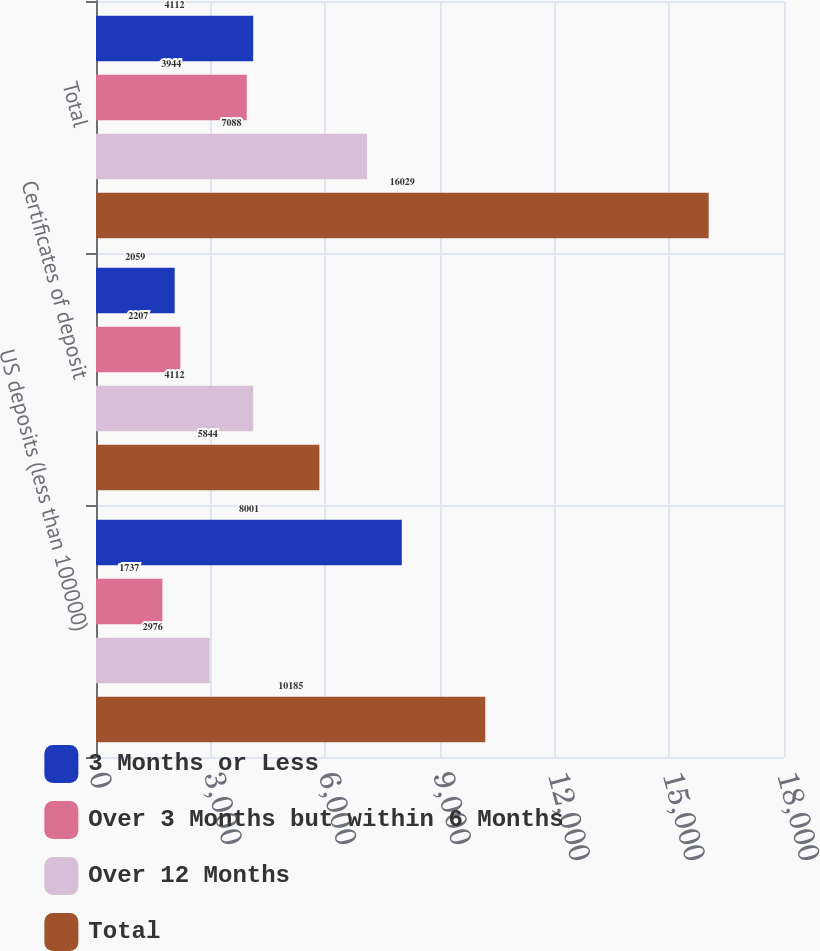Convert chart. <chart><loc_0><loc_0><loc_500><loc_500><stacked_bar_chart><ecel><fcel>US deposits (less than 100000)<fcel>Certificates of deposit<fcel>Total<nl><fcel>3 Months or Less<fcel>8001<fcel>2059<fcel>4112<nl><fcel>Over 3 Months but within 6 Months<fcel>1737<fcel>2207<fcel>3944<nl><fcel>Over 12 Months<fcel>2976<fcel>4112<fcel>7088<nl><fcel>Total<fcel>10185<fcel>5844<fcel>16029<nl></chart> 